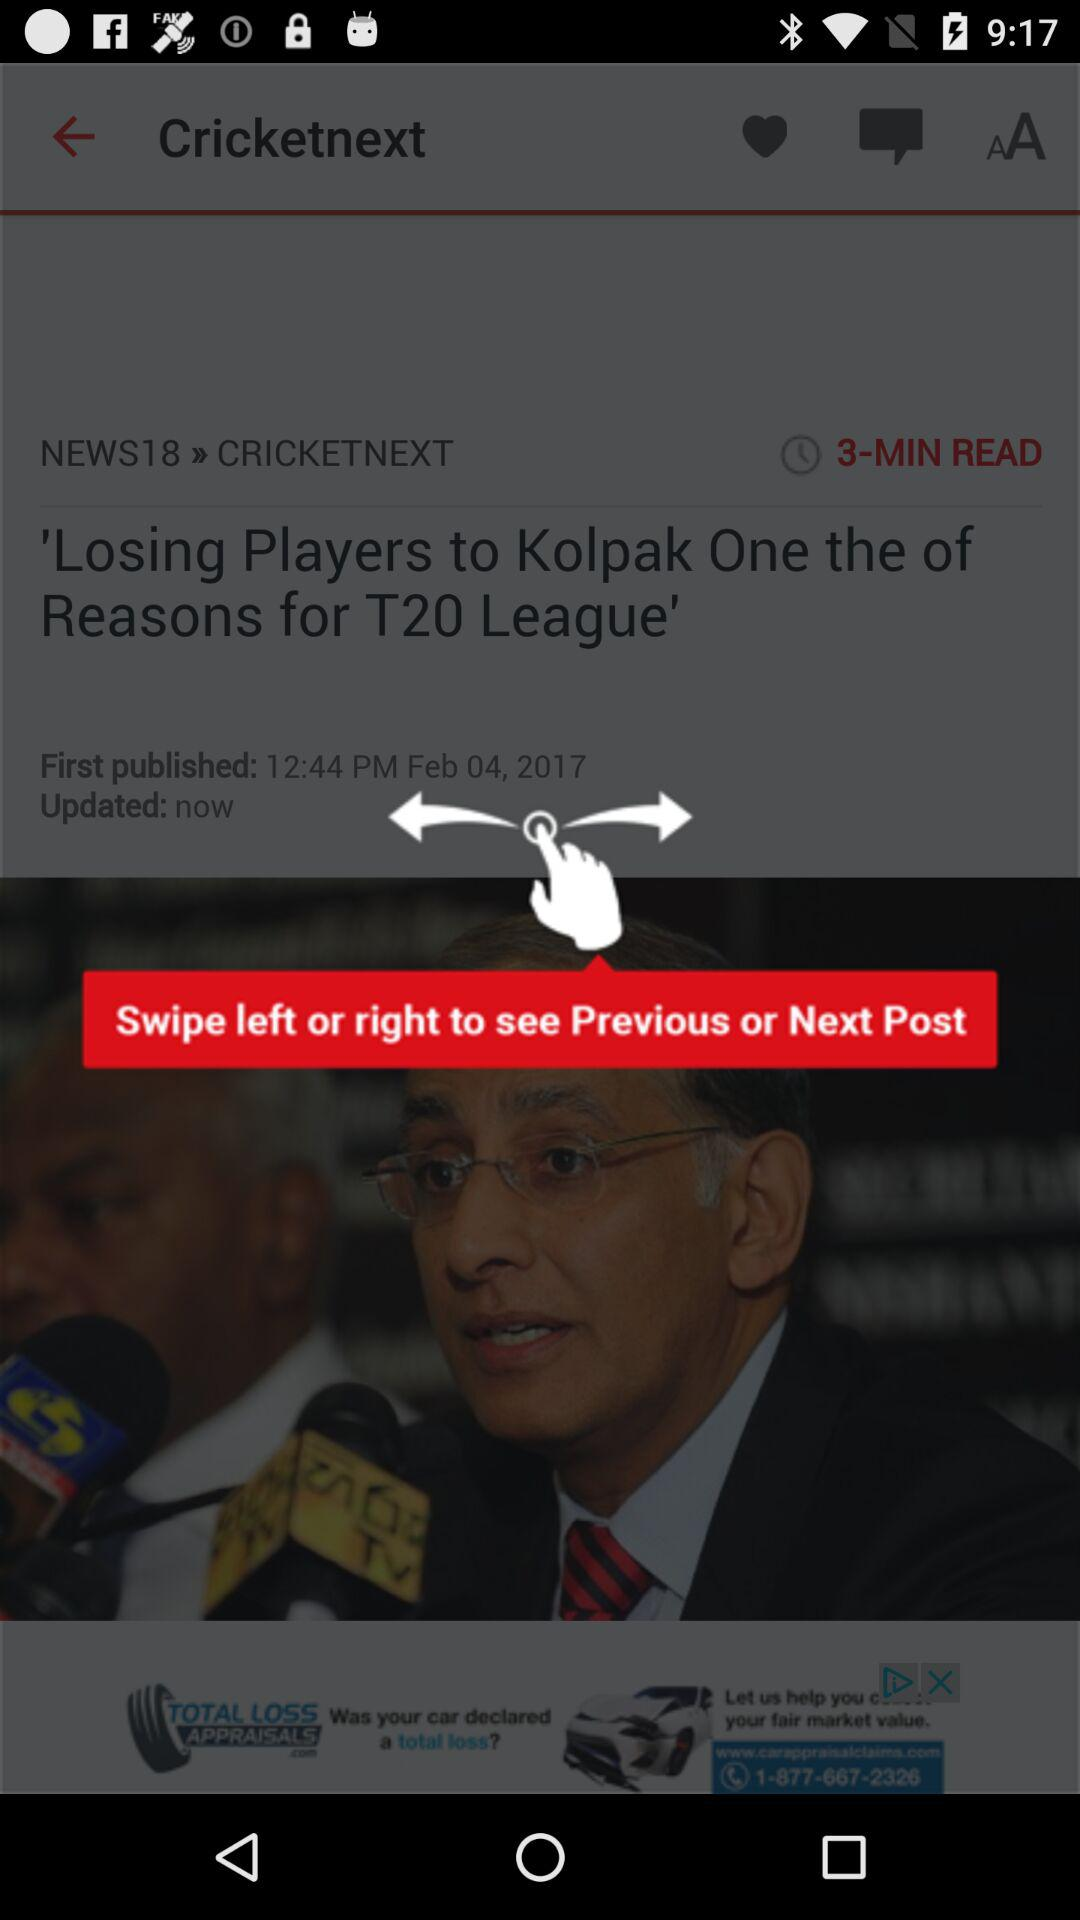When was the article published? The article was published on February 4, 2017. 